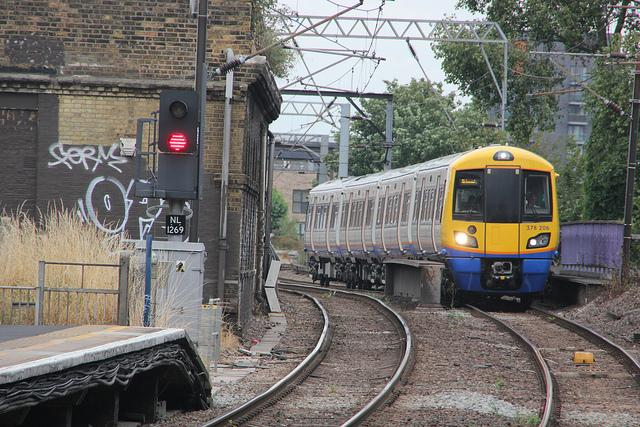This train is moved by what energy? Please explain your reasoning. electricity. The train is connected to power lines and runs on electricity. 